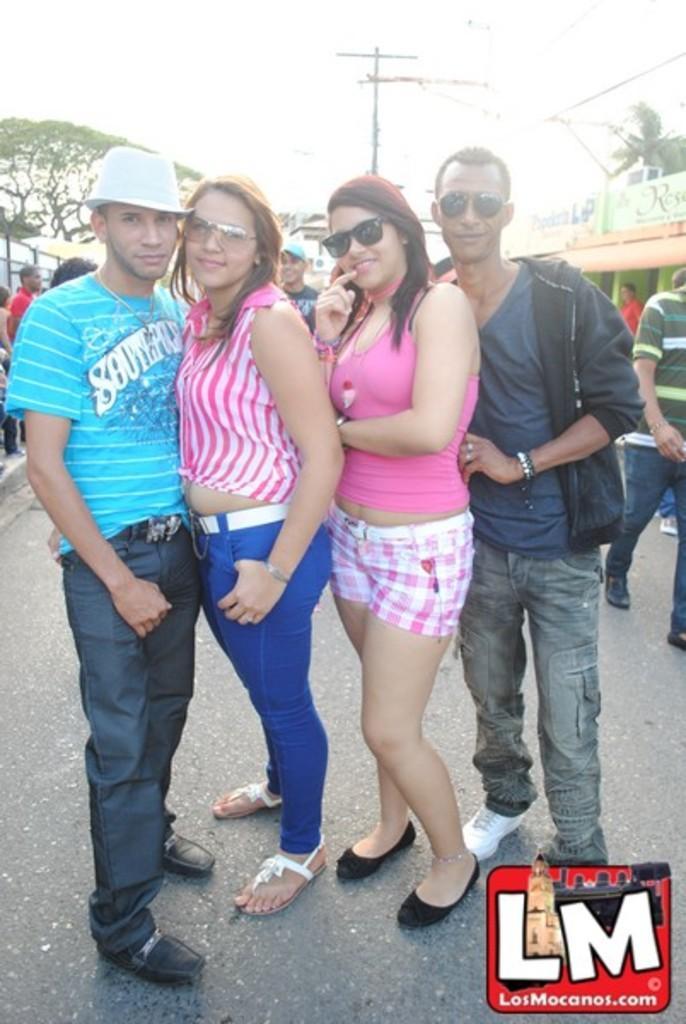Describe this image in one or two sentences. Here we can see four persons on the road. They are smiling and posing to a camera. In the background we can see trees, poles, boards, and sky. 